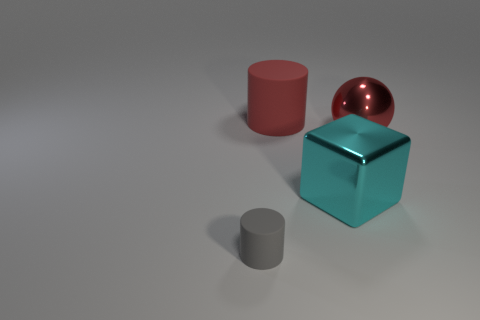Add 3 large red matte spheres. How many objects exist? 7 Subtract all blocks. How many objects are left? 3 Subtract all matte objects. Subtract all tiny purple cubes. How many objects are left? 2 Add 2 cyan metal blocks. How many cyan metal blocks are left? 3 Add 2 cyan shiny blocks. How many cyan shiny blocks exist? 3 Subtract 0 brown spheres. How many objects are left? 4 